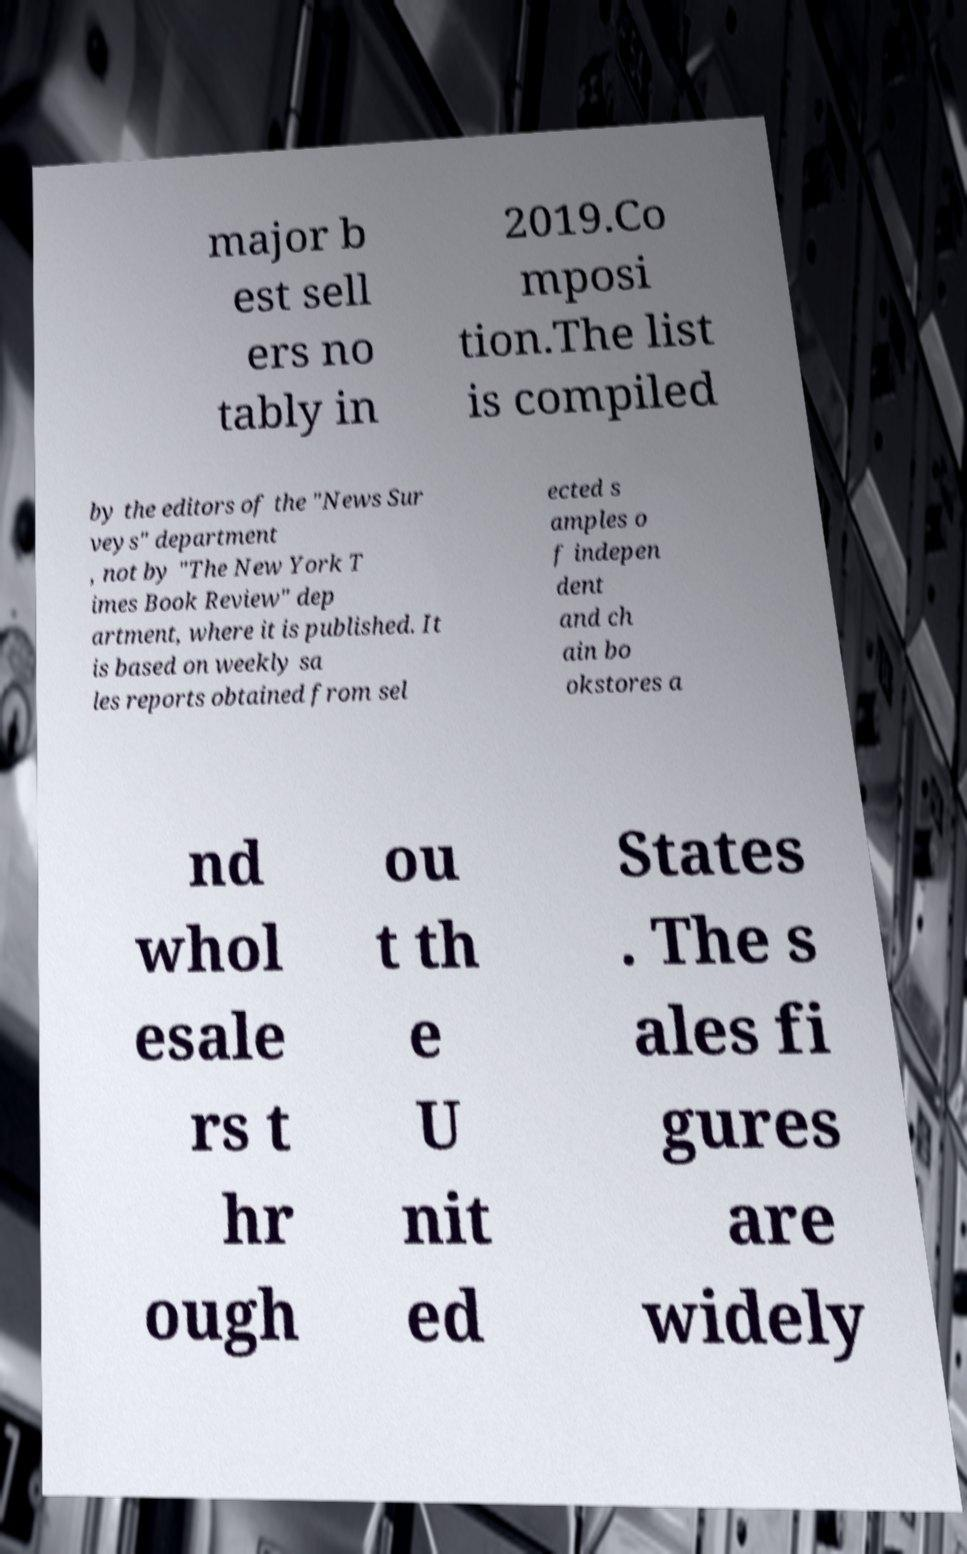Could you assist in decoding the text presented in this image and type it out clearly? major b est sell ers no tably in 2019.Co mposi tion.The list is compiled by the editors of the "News Sur veys" department , not by "The New York T imes Book Review" dep artment, where it is published. It is based on weekly sa les reports obtained from sel ected s amples o f indepen dent and ch ain bo okstores a nd whol esale rs t hr ough ou t th e U nit ed States . The s ales fi gures are widely 